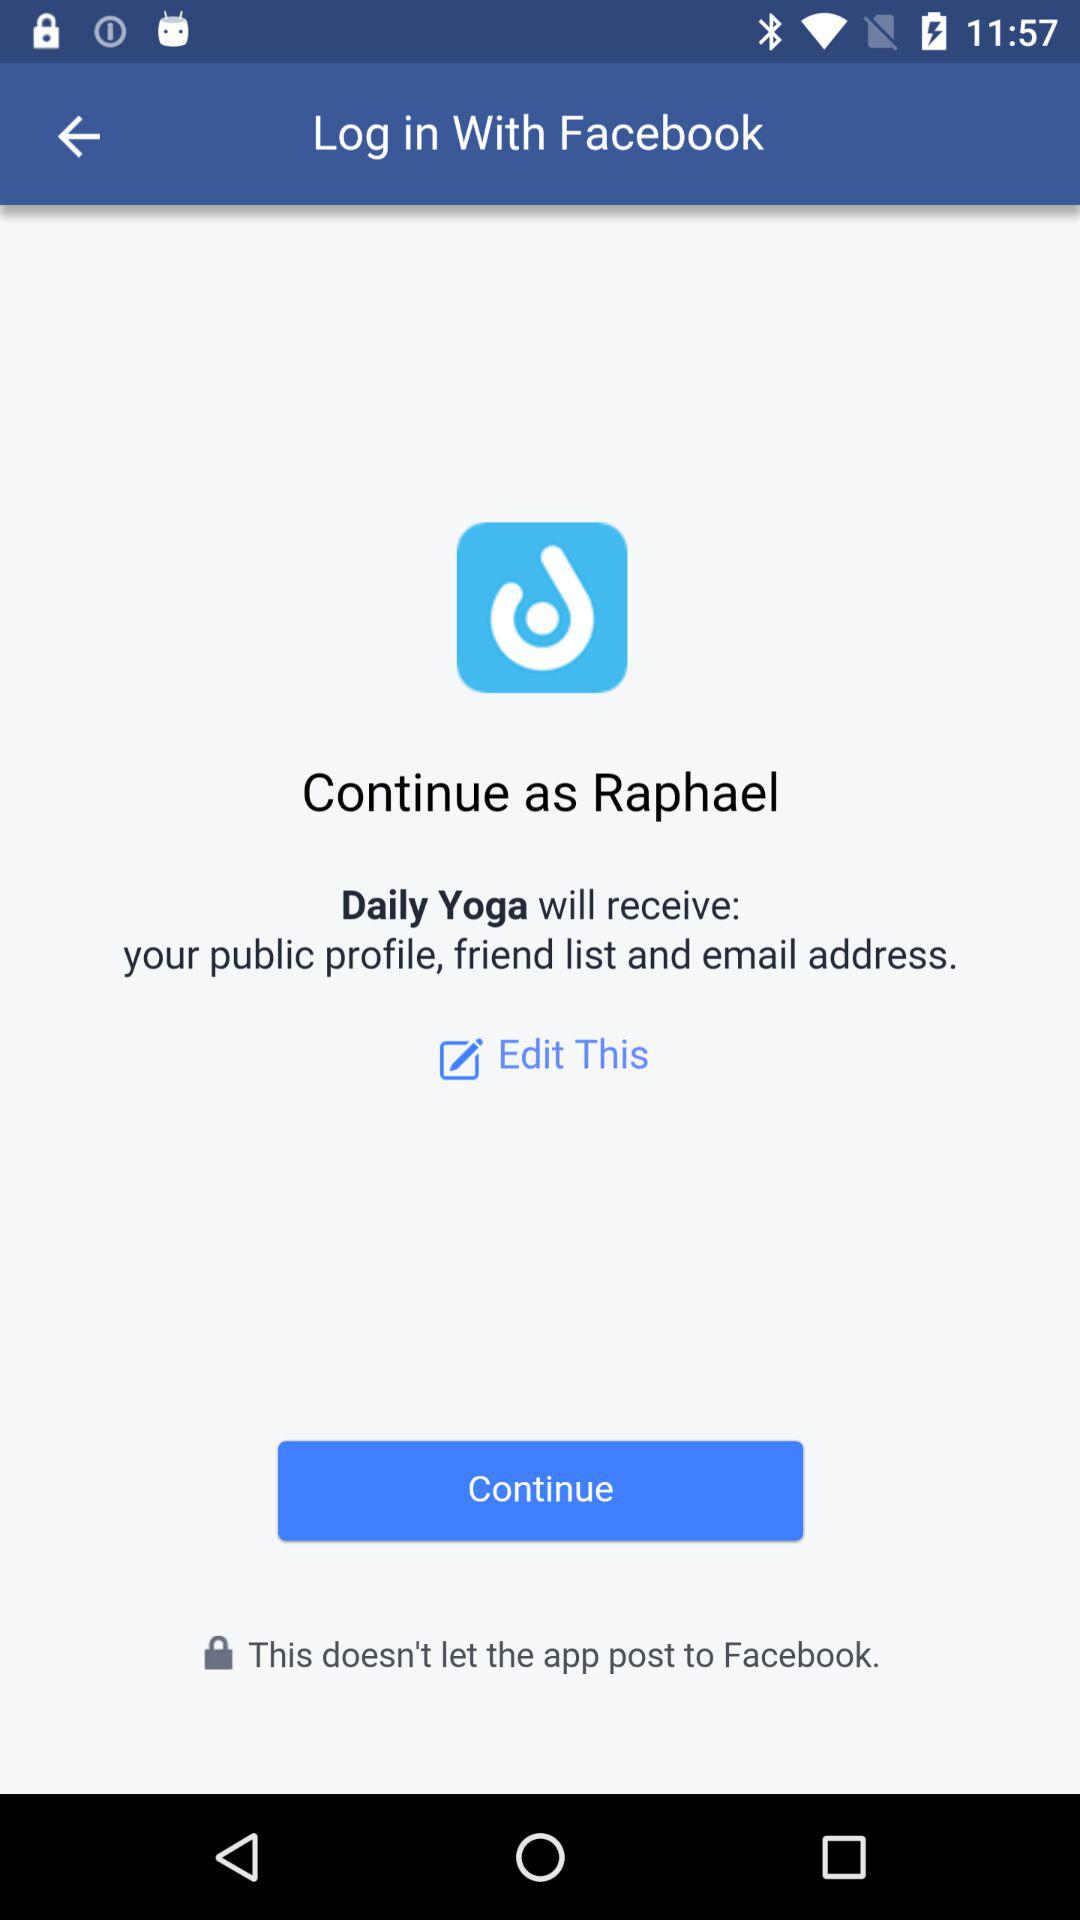Who will receive the public profile? The public profile will be received by "Daily Yoga". 